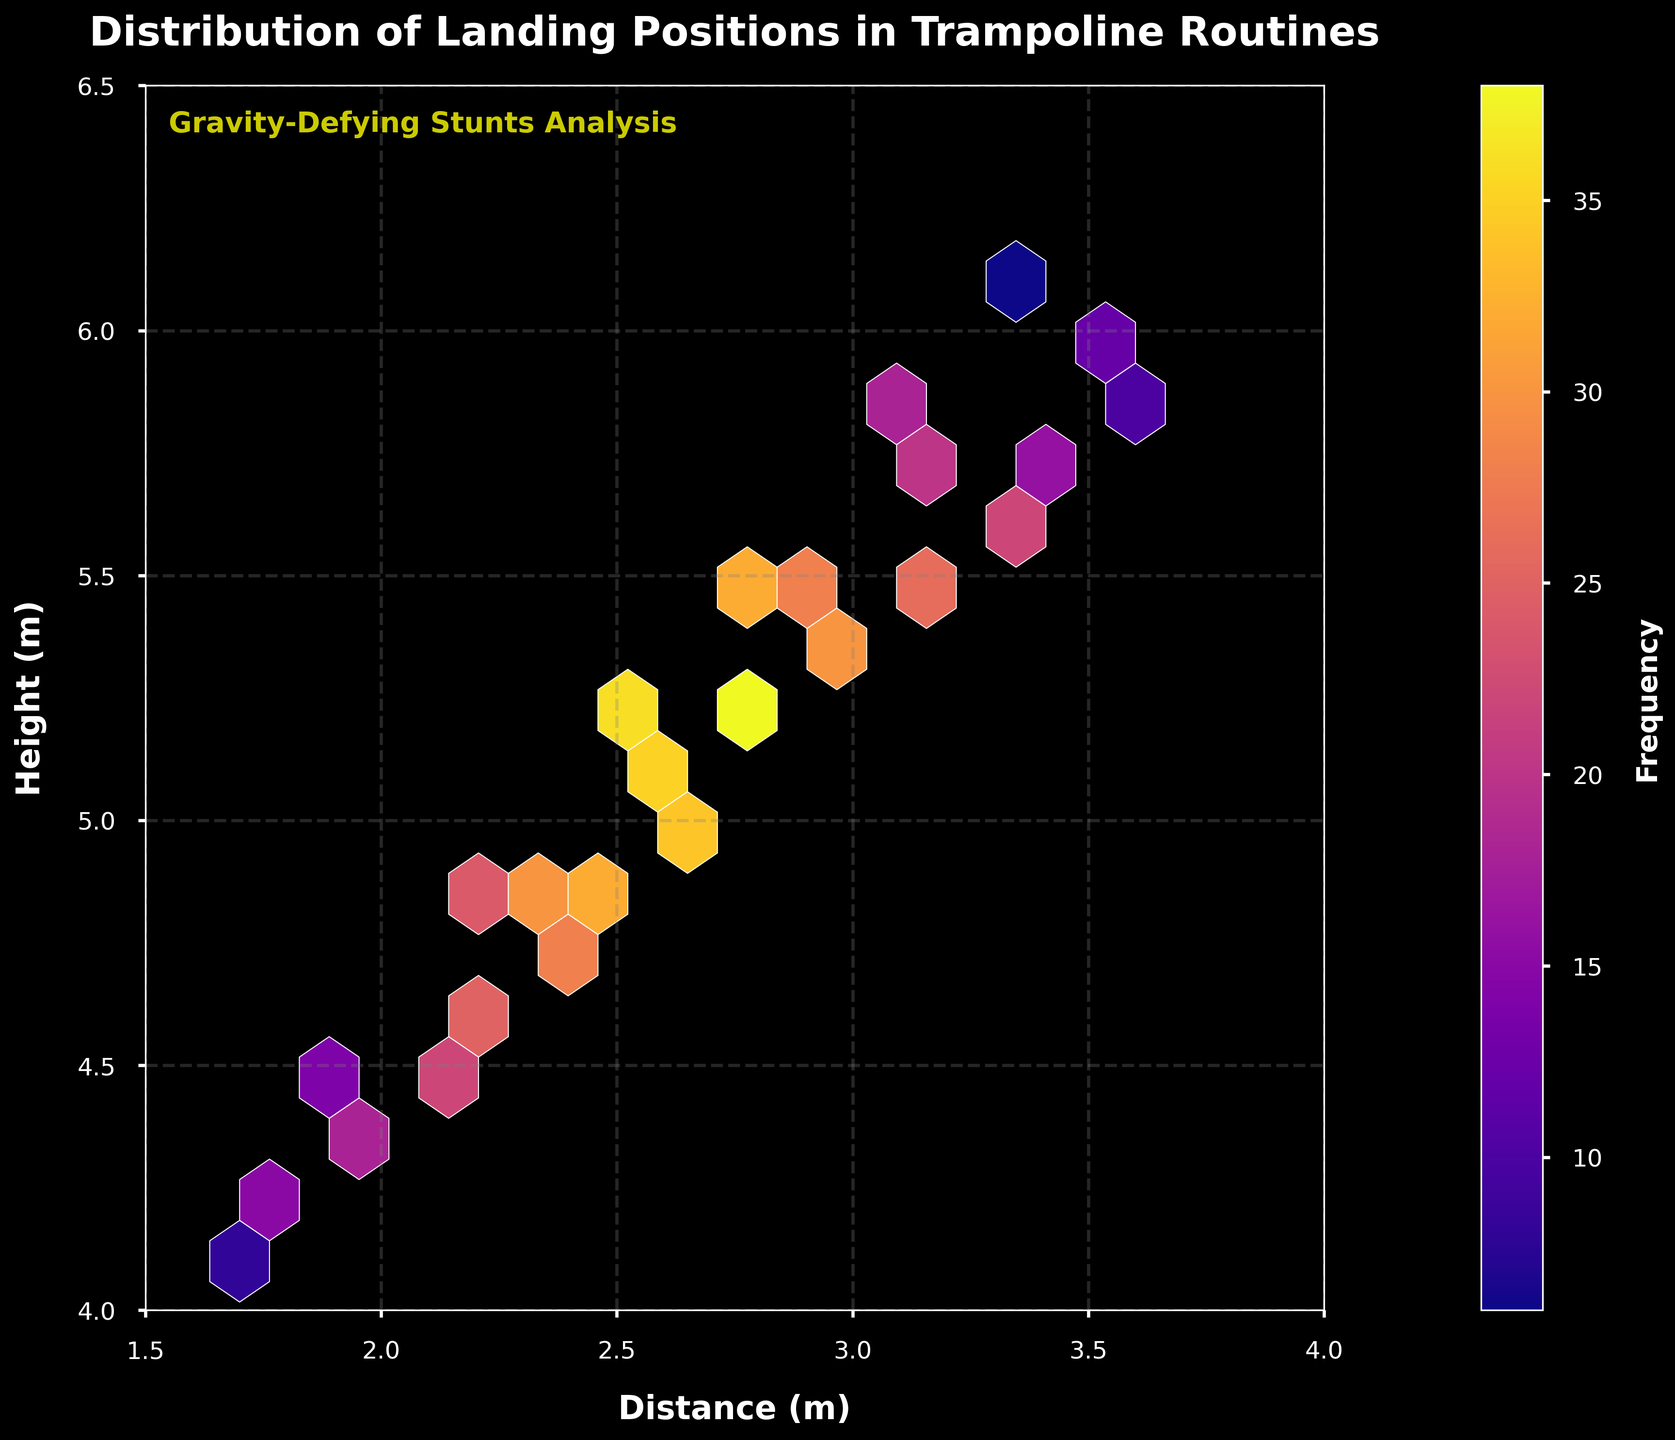What is the title of the hexbin plot? The title of the plot is usually displayed at the top of the figure. For this plot, it can be found at the top center.
Answer: Distribution of Landing Positions in Trampoline Routines What are the x-axis and y-axis labels? The x-axis label can be found at the bottom of the plot, and the y-axis label can be found on the left side of the plot.
Answer: Distance (m) and Height (m) What do the colors in the hexbin plot represent? The color of each hexbin represents the frequency of landing positions in that bin. The color bar on the right side of the plot shows this relationship.
Answer: Frequency What is the range of distances in the hexbin plot? The range of the x-axis tells us the limits of the distances plotted.
Answer: 1.5 to 4.0 meters How many hexagons display the highest frequency of landings and what color are they? To answer, locate the hexagons with the most intense color as indicated by the color bar.
Answer: One hexagon, shown in a deep purple color Between which heights do most landings occur? Examine where the highest concentration of hexagons is located on the y-axis.
Answer: 4.5 to 5.0 meters Which area on the plot shows the least frequency of landings? Look for the lightest colored or almost white hexagons which indicate the fewest landings.
Answer: Around (6.0, 3.5) and (6.1, 3.4) How does height correlate with distance in the landing positions? Observing the overall shape and trend of the hexbin distribution can help infer correlation.
Answer: Positive correlation Compare the frequency of landings at Distance 2.8m for heights 5.2m and 5.5m. Which is higher? Find the hexagons corresponding to these coordinates and compare the color intensities.
Answer: Height 5.2m has higher frequency 